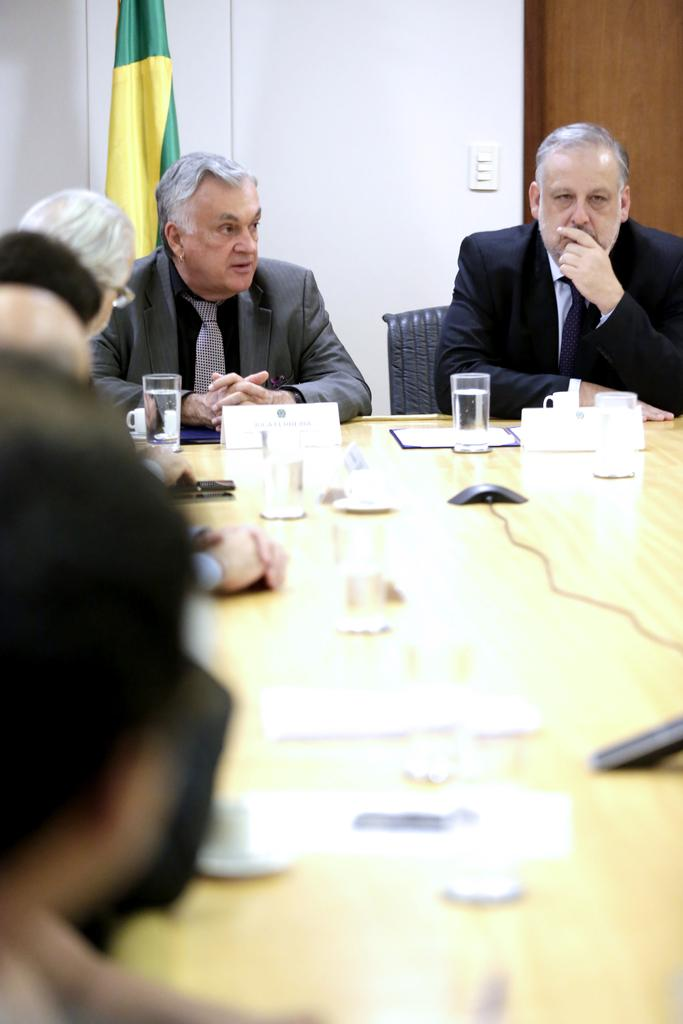What is the main piece of furniture in the image? There is a table in the image. What objects are on the table? There are glasses and a mouse on the table. What are the people around the table doing? People are seated around the table. What color are the chairs? The chairs are black. What are the people wearing? The people are wearing suits. What can be seen in the background of the image? There is a flag and a white wall in the background. What architectural feature is on the right side of the image? There is a door on the right side of the image. What time of day is it in the image, and what type of milk is being served? The time of day cannot be determined from the image, and there is no milk present in the image. 